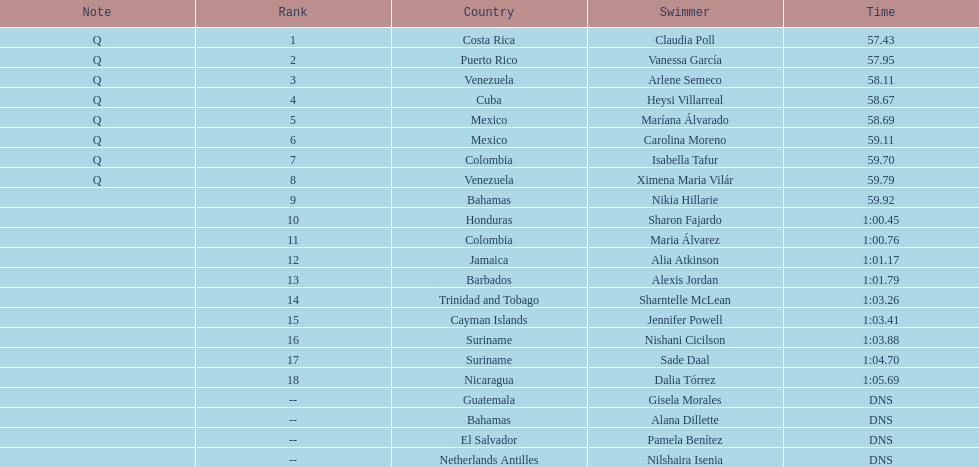Which swimmer had the longest time? Dalia Tórrez. 